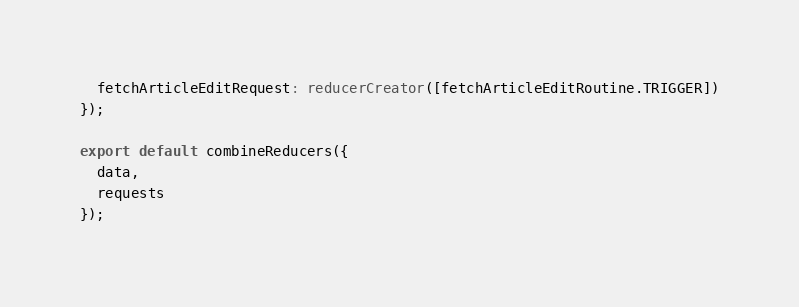<code> <loc_0><loc_0><loc_500><loc_500><_TypeScript_>  fetchArticleEditRequest: reducerCreator([fetchArticleEditRoutine.TRIGGER])
});

export default combineReducers({
  data,
  requests
});
</code> 